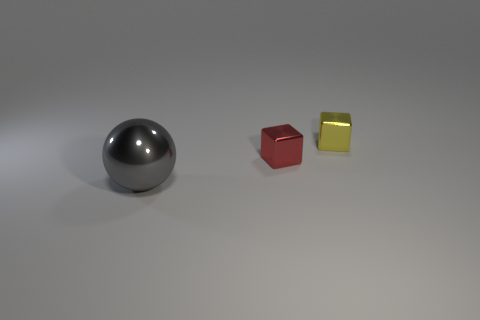Add 2 small yellow metallic cubes. How many objects exist? 5 Subtract all cubes. How many objects are left? 1 Subtract all yellow things. Subtract all yellow rubber things. How many objects are left? 2 Add 2 small red metal objects. How many small red metal objects are left? 3 Add 2 big brown rubber balls. How many big brown rubber balls exist? 2 Subtract 0 cyan cylinders. How many objects are left? 3 